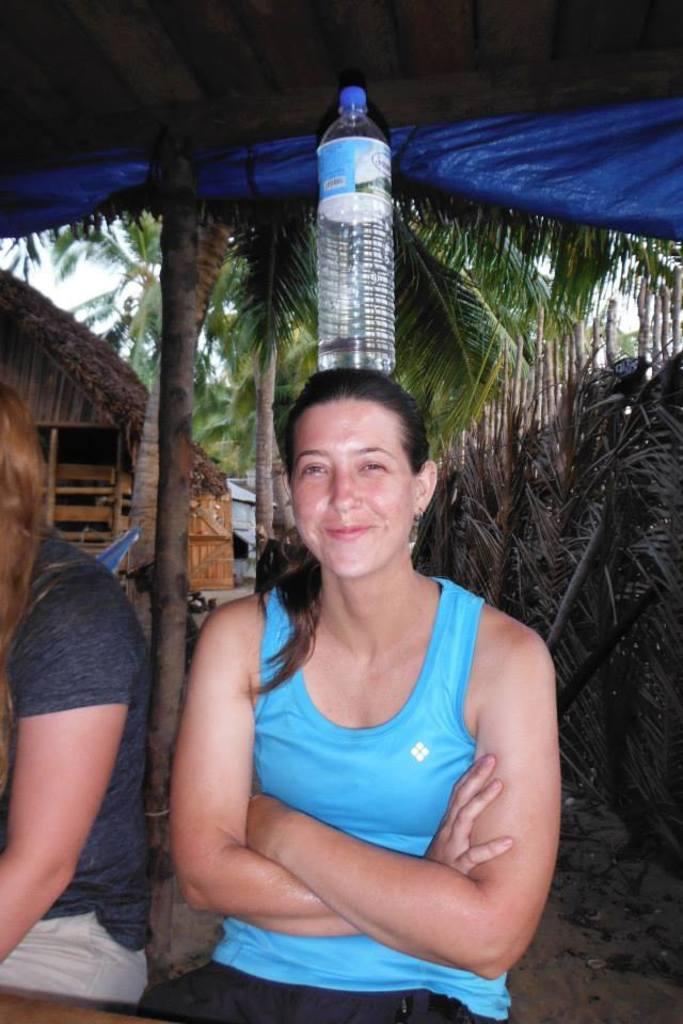Can you describe this image briefly? As we can see in the image there are trees, two persons and a bottle. 